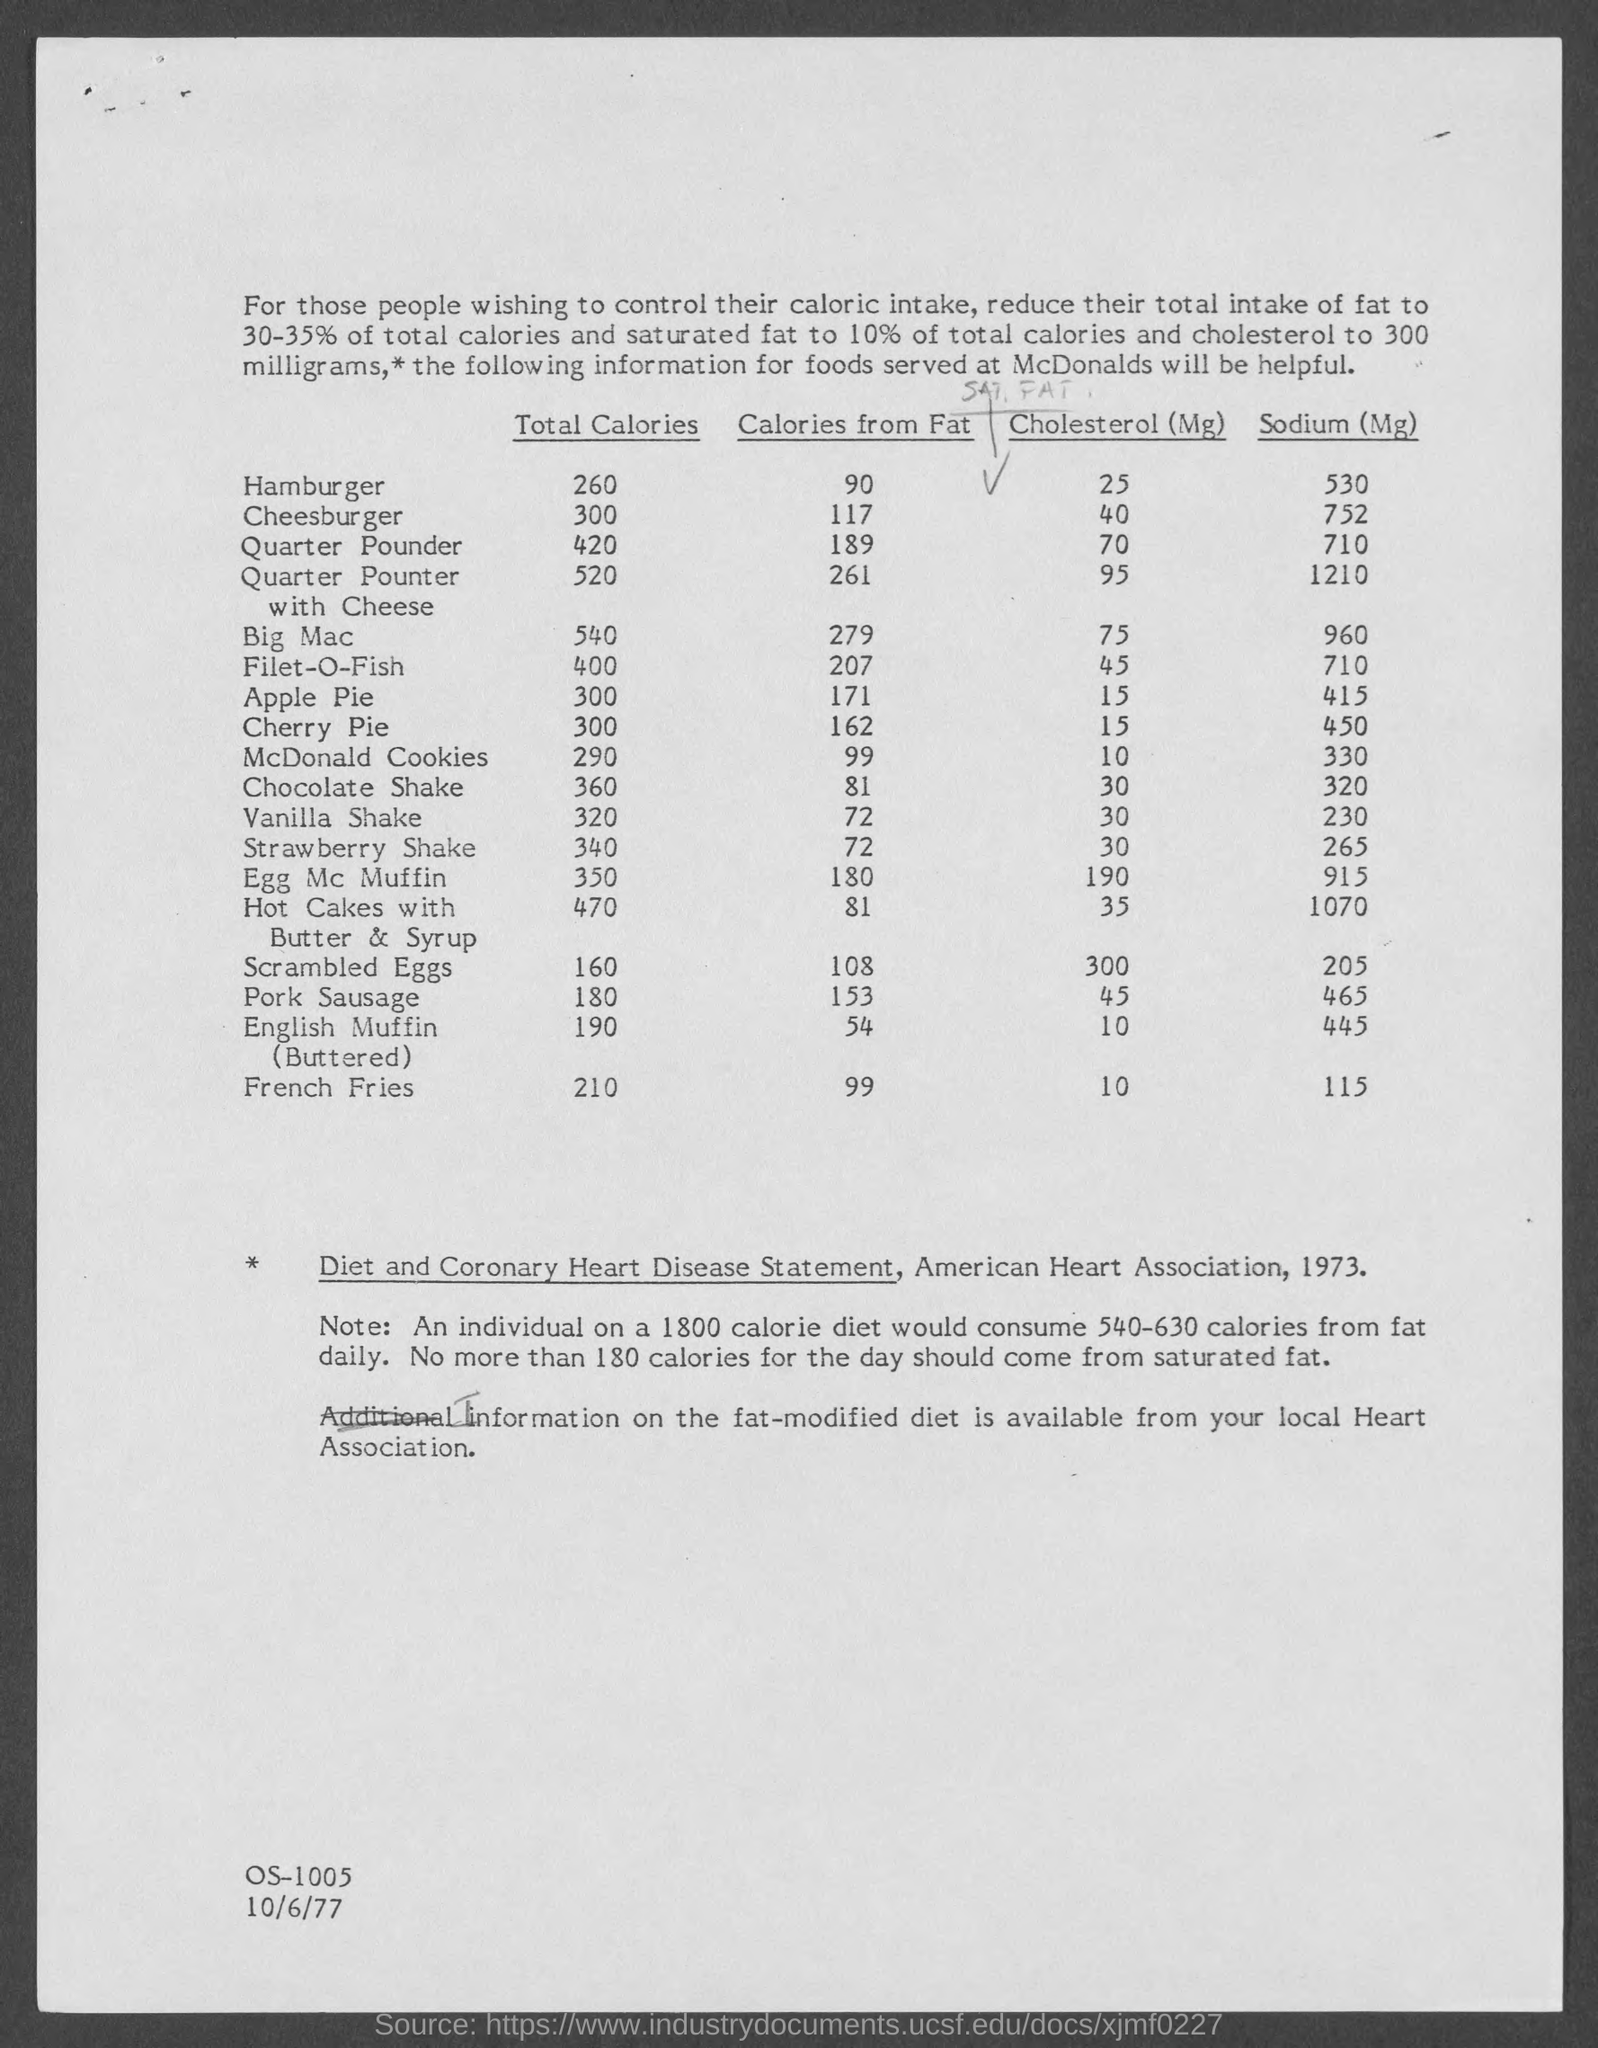What is the date mentioned in the document?
Offer a very short reply. 10/6/77. What is the total calorie of french fries?
Your answer should be very brief. 210. What is the total calorie of an apple pie?
Your response must be concise. 300. What is the total calorie of a cheeseburger?
Your response must be concise. 300. What is the amount of sodium in a hamburger?
Ensure brevity in your answer.  530. What is the amount of sodium in french fries?
Give a very brief answer. 115. What is the amount of cholesterol in french fries?
Keep it short and to the point. 10. What is the amount of cholesterol in pork sausage?
Offer a terse response. 45. What is the amount of calories from fat in pork sausage?
Your response must be concise. 153. What is the amount of calories from fat in a hamburger?
Keep it short and to the point. 90. 